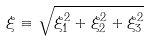Convert formula to latex. <formula><loc_0><loc_0><loc_500><loc_500>\xi \equiv \sqrt { \xi ^ { 2 } _ { 1 } + \xi ^ { 2 } _ { 2 } + \xi ^ { 2 } _ { 3 } }</formula> 